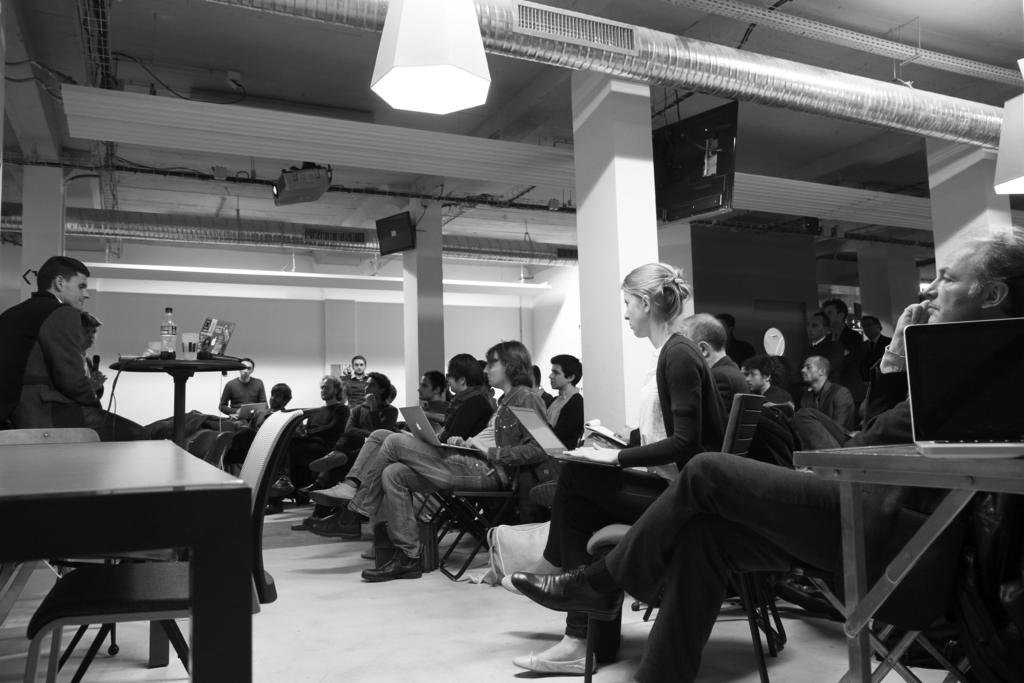What is the color of the wall in the image? The wall in the image is white. What device is present in the image for displaying visuals? There is a projector in the image. What are the people in the image doing? The people in the image are sitting on chairs. What electronic device is visible in the image? There is a laptop in the image. What piece of furniture is present in the image? There is a table in the image. What type of glassware is present in the image? There is a glass in the image. What type of container is present in the image? There is a bottle in the image. What type of mist is present in the image? There is no mist present in the image. What organization is responsible for the event in the image? The image does not provide information about any organization or event. What type of beast can be seen in the image? There is no beast present in the image. 